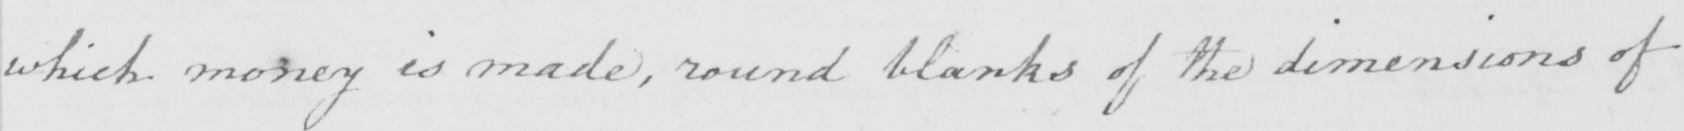Can you tell me what this handwritten text says? which money is made , round blanks of the dimensions of 